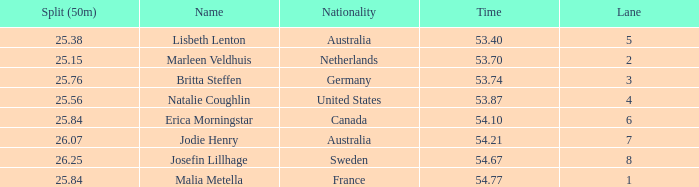What is the slowest 50m split time for a total of 53.74 in a lane of less than 3? None. 